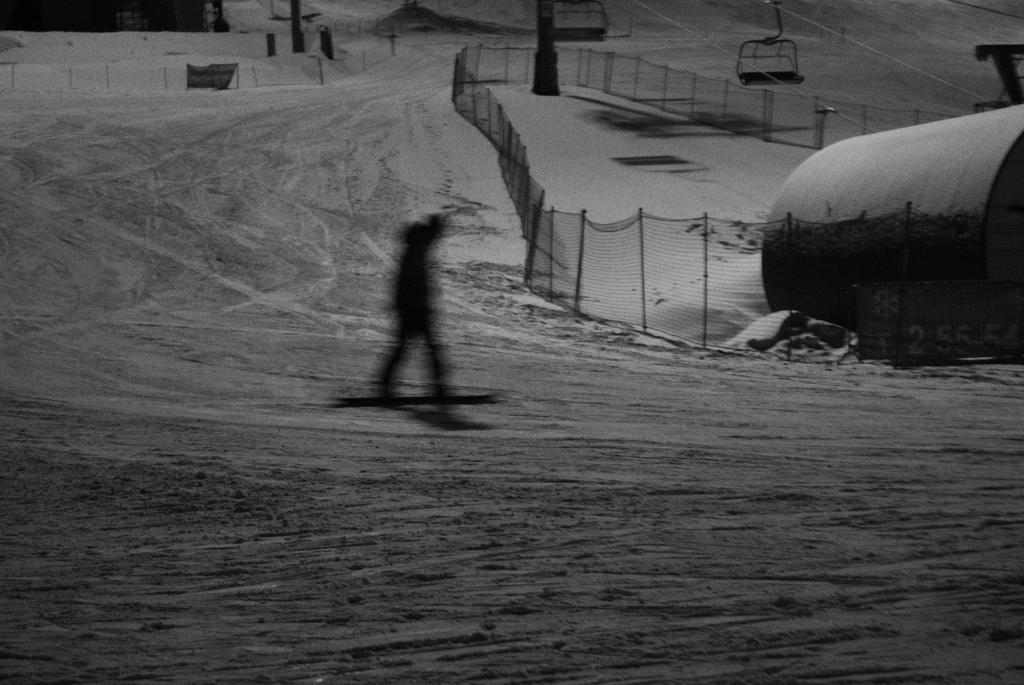What is the main activity being performed in the image? There is a person riding a snowboard on the snow surface of a ground. What can be seen in the background of the image? There is a fencing in the background, along with other objects. What type of square can be seen in the downtown area in the image? There is no square or downtown area present in the image; it features a person snowboarding with a fencing and other objects in the background. 